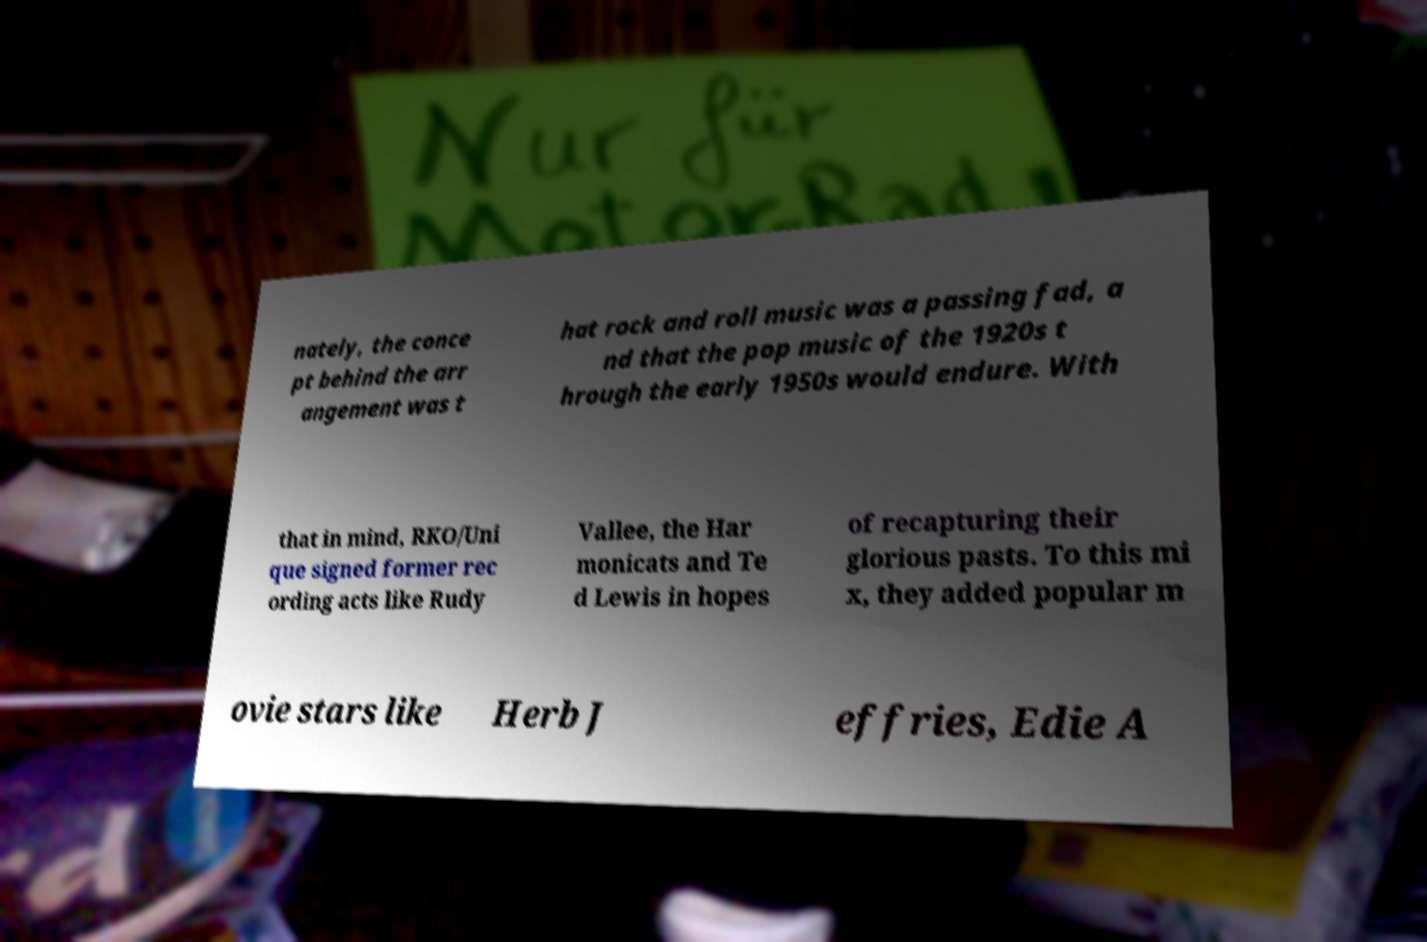There's text embedded in this image that I need extracted. Can you transcribe it verbatim? nately, the conce pt behind the arr angement was t hat rock and roll music was a passing fad, a nd that the pop music of the 1920s t hrough the early 1950s would endure. With that in mind, RKO/Uni que signed former rec ording acts like Rudy Vallee, the Har monicats and Te d Lewis in hopes of recapturing their glorious pasts. To this mi x, they added popular m ovie stars like Herb J effries, Edie A 